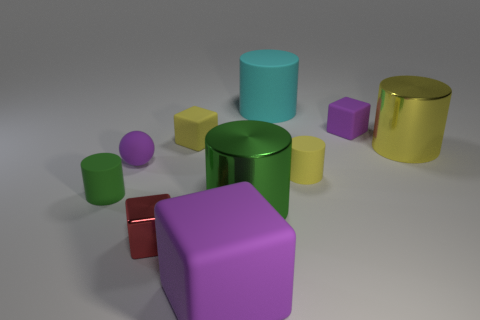There is a purple matte block behind the yellow block; is its size the same as the big yellow cylinder?
Ensure brevity in your answer.  No. There is a shiny object left of the purple matte cube that is in front of the red thing; what is its shape?
Ensure brevity in your answer.  Cube. There is a purple thing in front of the tiny green matte object that is in front of the small purple ball; what size is it?
Provide a short and direct response. Large. The small matte cylinder to the right of the small metallic thing is what color?
Make the answer very short. Yellow. What is the size of the yellow thing that is the same material as the red thing?
Provide a succinct answer. Large. What number of red things are the same shape as the small green matte object?
Make the answer very short. 0. There is a cube that is the same size as the cyan matte cylinder; what is it made of?
Keep it short and to the point. Rubber. Are there any small blocks that have the same material as the large green cylinder?
Provide a succinct answer. Yes. What color is the matte cylinder that is both on the right side of the tiny shiny block and in front of the large cyan thing?
Your response must be concise. Yellow. What number of other things are the same color as the small shiny cube?
Ensure brevity in your answer.  0. 